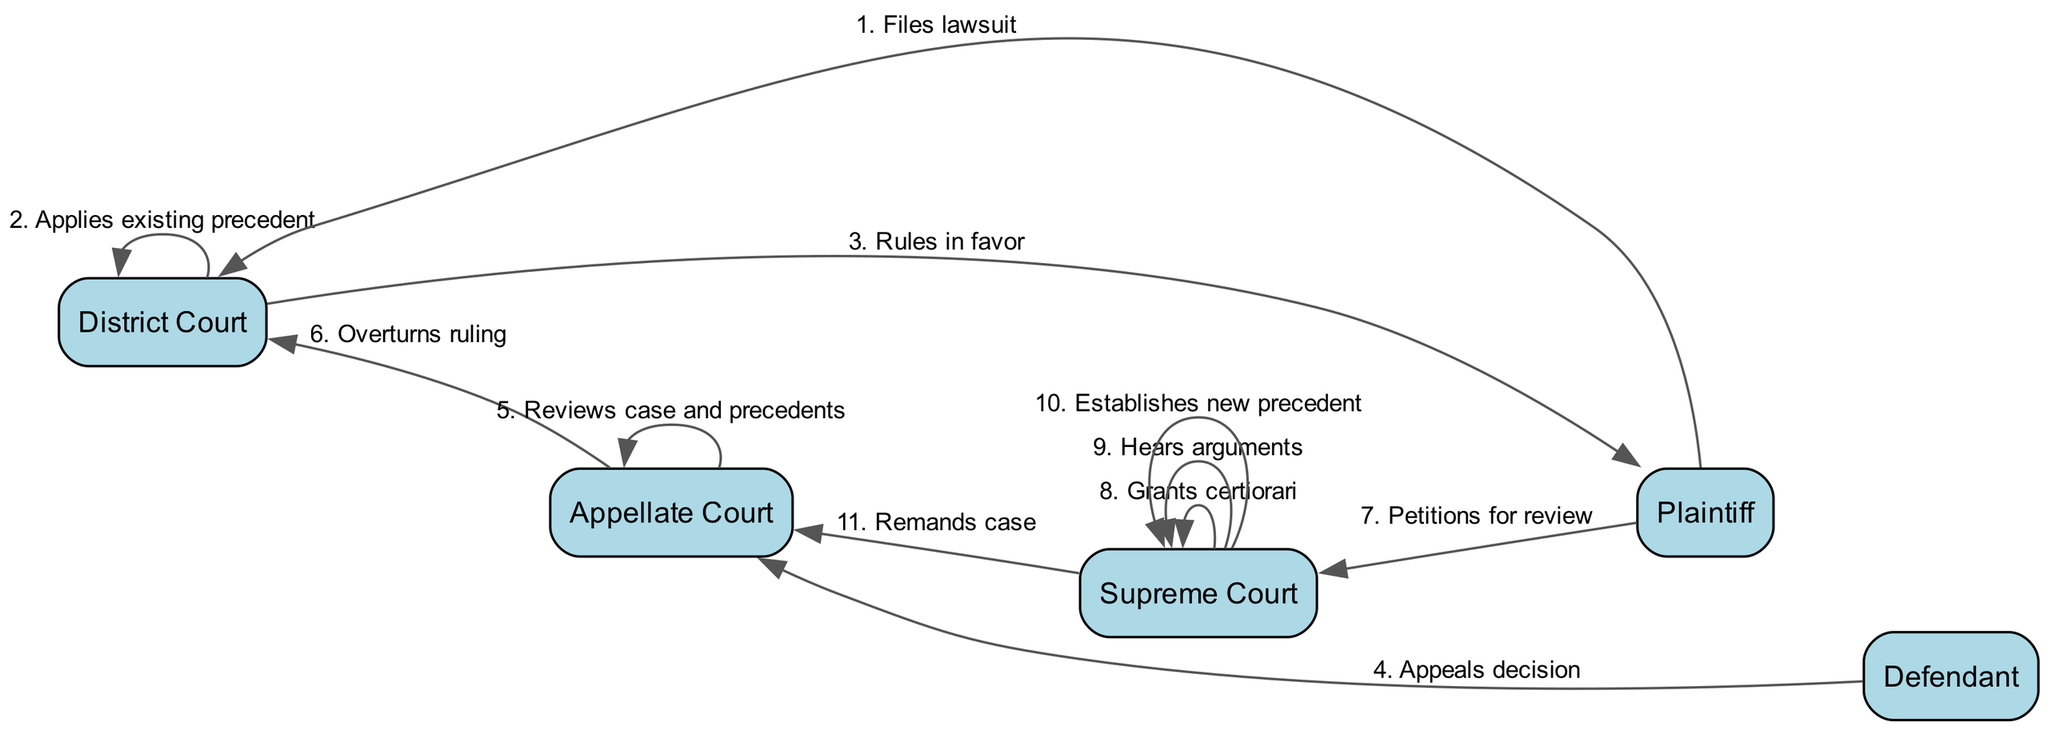What is the first action in the sequence? The first action in the sequence is "Files lawsuit," which is initiated by the Plaintiff to the District Court.
Answer: Files lawsuit How many total actions are depicted in the diagram? There are a total of 11 actions depicted in the sequence, as counted from the sequence list.
Answer: 11 What action takes place after the Appellate Court reviews the case? After the Appellate Court reviews the case and precedents, the next action is to "Overturns ruling."
Answer: Overturns ruling Which actor petitions for review at the Supreme Court? The Plaintiff is the actor who petitions for review at the Supreme Court, as indicated in the flow of actions.
Answer: Plaintiff What is the outcome established by the Supreme Court? The outcome established by the Supreme Court is "Establishes new precedent," which indicates a significant change in legal precedent.
Answer: Establishes new precedent Which court sends the case back to the Appellate Court? The Supreme Court sends the case back to the Appellate Court after establishing a new precedent, indicating a remand of the case.
Answer: Supreme Court What type of action does the District Court take after receiving the lawsuit? The District Court takes the action "Applies existing precedent" after receiving the lawsuit from the Plaintiff, indicating its reliance on established laws.
Answer: Applies existing precedent How many times does the Supreme Court perform internal actions? The Supreme Court performs 3 internal actions: grants certiorari, hears arguments, and establishes new precedent.
Answer: 3 What action is taken by the Defendant in the sequence? The Defendant takes the action "Appeals decision" to the Appellate Court after the District Court rules in favor of the Plaintiff.
Answer: Appeals decision Which two actors are involved in the last action of the sequence? The last action involves the Supreme Court and the Appellate Court, specifically where the Supreme Court remands the case.
Answer: Supreme Court, Appellate Court 